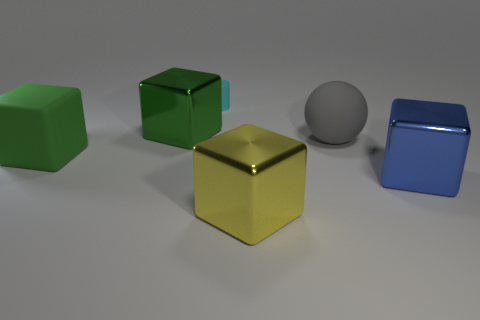How do the colors of the objects contrast with one another and with the background? The objects' colors create a harmonious contrast. The green and blue hues of the cubes are analogous, lying close together on the color wheel, while the golden cube contrasts with both as a complementary color to blue. The grey background offers a neutral canvas, preventing any color from dominating and allowing each object to stand out on its own merit. Do these colors have any symbolic meanings or associations in design? Colors carry various symbolic meanings. Green often represents growth and tranquility, while blue can symbolize stability and calm. Gold is associated with wealth and prestige. In design, these colors can be used to evoke these emotions or to serve functional purposes based on cultural contexts and design principles. 